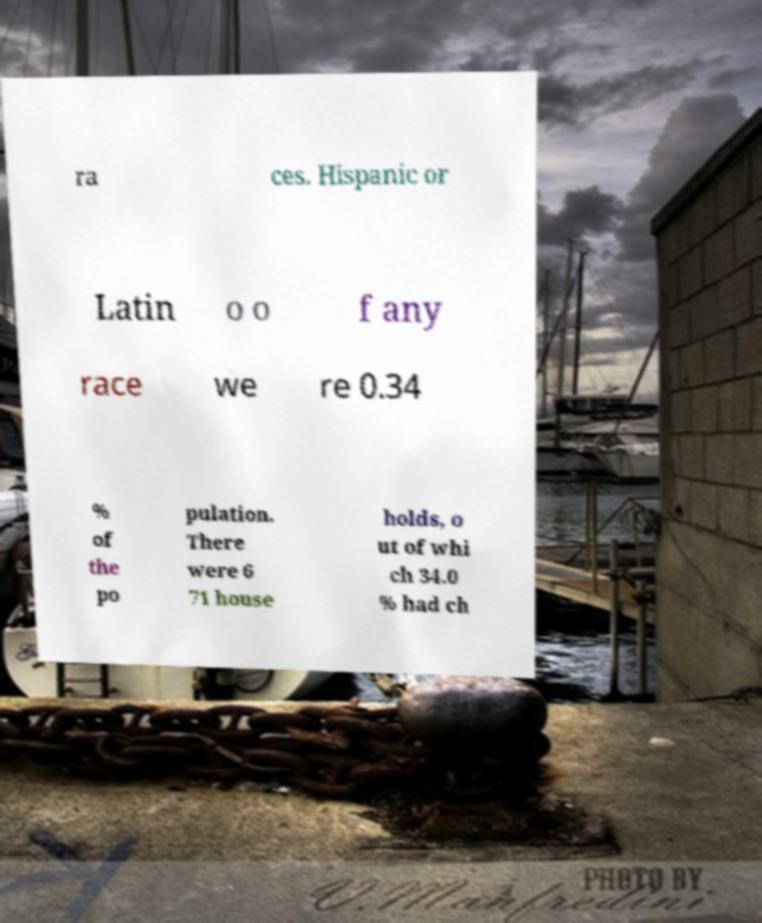Could you extract and type out the text from this image? ra ces. Hispanic or Latin o o f any race we re 0.34 % of the po pulation. There were 6 71 house holds, o ut of whi ch 34.0 % had ch 